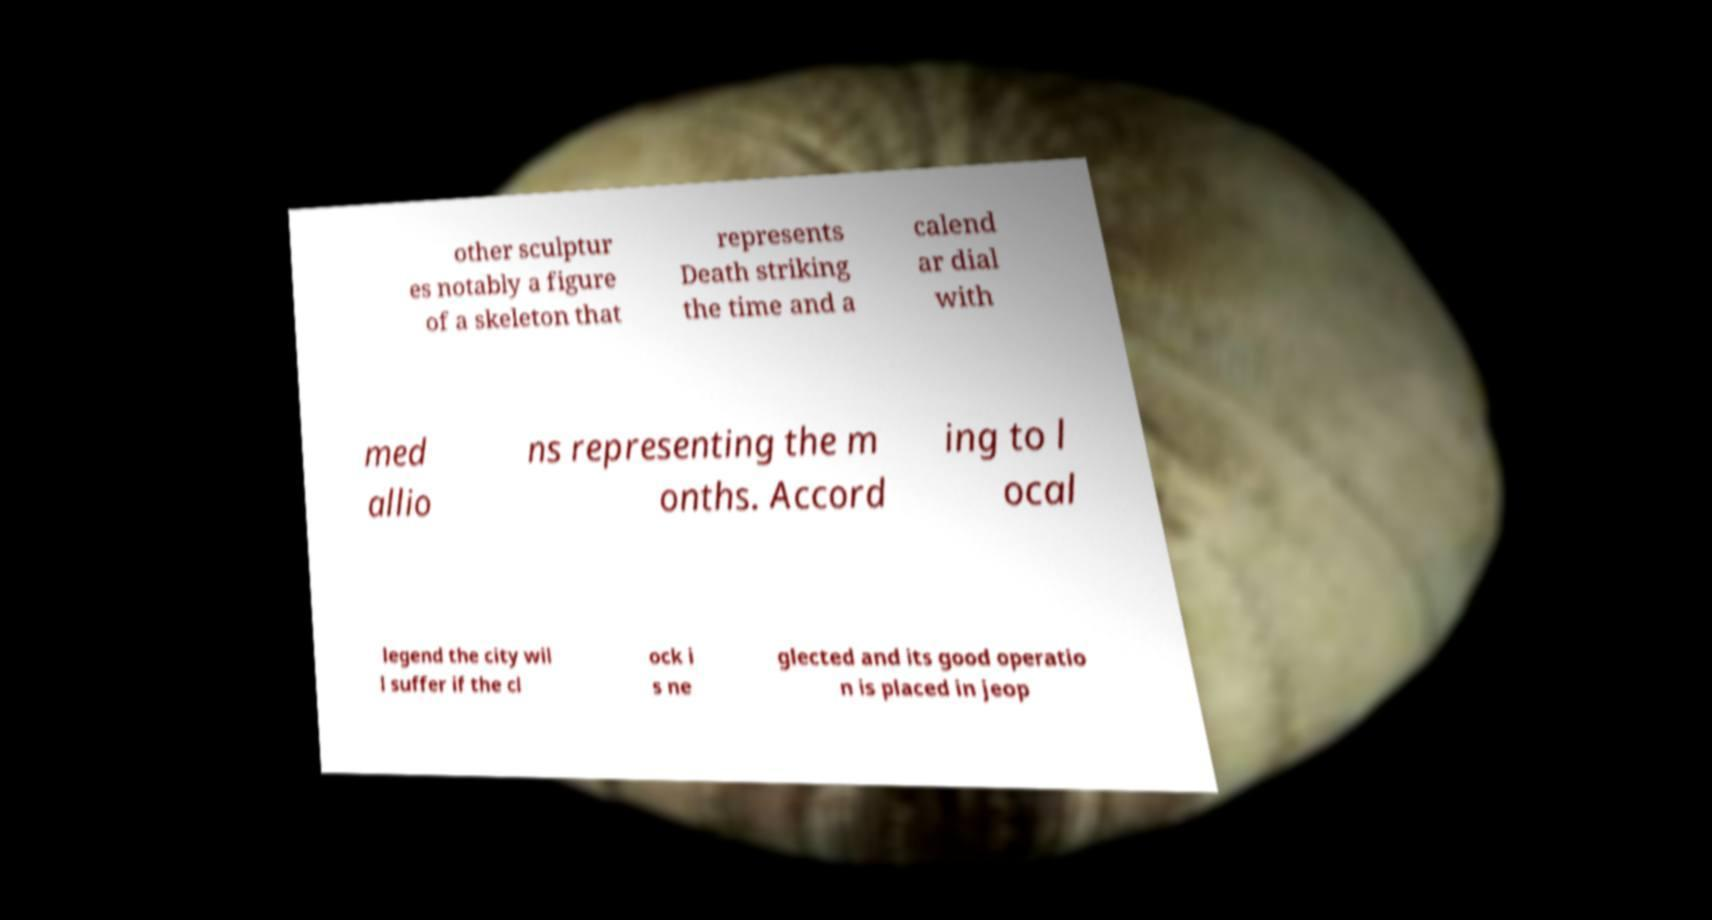There's text embedded in this image that I need extracted. Can you transcribe it verbatim? other sculptur es notably a figure of a skeleton that represents Death striking the time and a calend ar dial with med allio ns representing the m onths. Accord ing to l ocal legend the city wil l suffer if the cl ock i s ne glected and its good operatio n is placed in jeop 